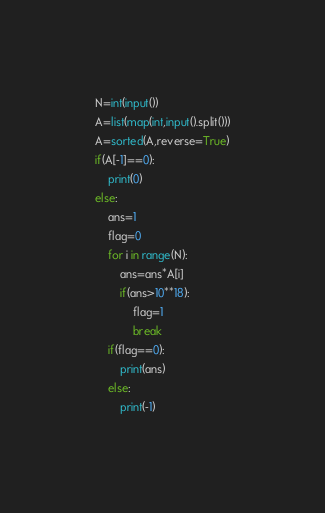<code> <loc_0><loc_0><loc_500><loc_500><_Python_>N=int(input())
A=list(map(int,input().split()))
A=sorted(A,reverse=True)
if(A[-1]==0):
    print(0)
else:
    ans=1
    flag=0
    for i in range(N):
        ans=ans*A[i]
        if(ans>10**18):
            flag=1
            break
    if(flag==0):
        print(ans)
    else:
        print(-1)</code> 